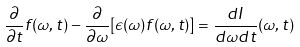<formula> <loc_0><loc_0><loc_500><loc_500>\frac { \partial } { \partial t } f ( \omega , t ) - \frac { \partial } { \partial \omega } [ \epsilon ( \omega ) f ( \omega , t ) ] = \frac { d I } { d \omega d t } ( \omega , t )</formula> 